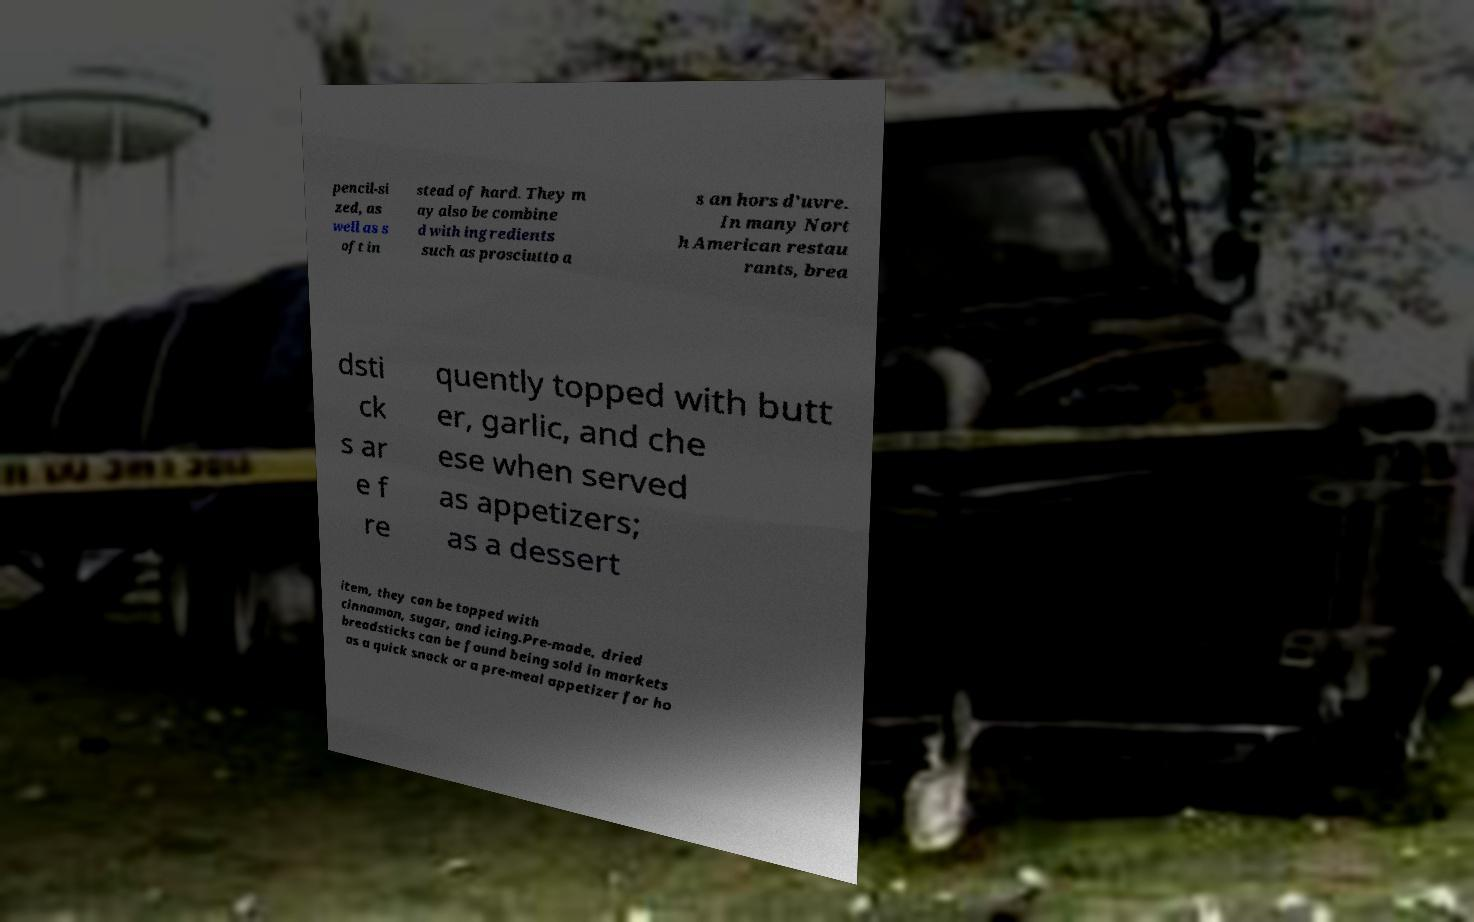Could you assist in decoding the text presented in this image and type it out clearly? pencil-si zed, as well as s oft in stead of hard. They m ay also be combine d with ingredients such as prosciutto a s an hors d'uvre. In many Nort h American restau rants, brea dsti ck s ar e f re quently topped with butt er, garlic, and che ese when served as appetizers; as a dessert item, they can be topped with cinnamon, sugar, and icing.Pre-made, dried breadsticks can be found being sold in markets as a quick snack or a pre-meal appetizer for ho 